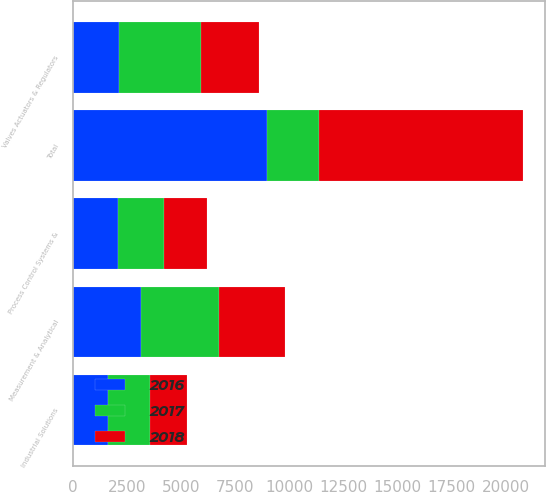<chart> <loc_0><loc_0><loc_500><loc_500><stacked_bar_chart><ecel><fcel>Measurement & Analytical<fcel>Valves Actuators & Regulators<fcel>Industrial Solutions<fcel>Process Control Systems &<fcel>Total<nl><fcel>2016<fcel>3137<fcel>2137<fcel>1621<fcel>2082<fcel>8977<nl><fcel>2018<fcel>3070<fcel>2668<fcel>1680<fcel>2000<fcel>9418<nl><fcel>2017<fcel>3604<fcel>3769<fcel>1947<fcel>2121<fcel>2402.5<nl></chart> 